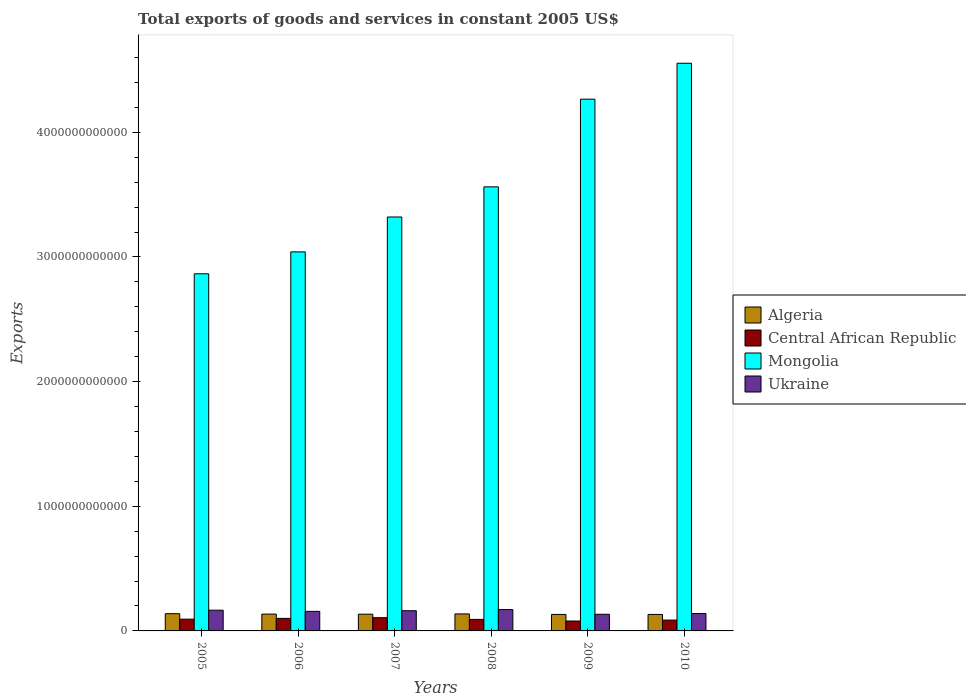How many groups of bars are there?
Provide a short and direct response. 6. How many bars are there on the 2nd tick from the right?
Make the answer very short. 4. What is the label of the 3rd group of bars from the left?
Your answer should be compact. 2007. What is the total exports of goods and services in Central African Republic in 2006?
Make the answer very short. 1.01e+11. Across all years, what is the maximum total exports of goods and services in Mongolia?
Your answer should be compact. 4.55e+12. Across all years, what is the minimum total exports of goods and services in Central African Republic?
Provide a succinct answer. 7.96e+1. In which year was the total exports of goods and services in Ukraine maximum?
Make the answer very short. 2008. What is the total total exports of goods and services in Ukraine in the graph?
Your answer should be very brief. 9.30e+11. What is the difference between the total exports of goods and services in Central African Republic in 2005 and that in 2008?
Give a very brief answer. 1.77e+09. What is the difference between the total exports of goods and services in Ukraine in 2007 and the total exports of goods and services in Algeria in 2008?
Make the answer very short. 2.56e+1. What is the average total exports of goods and services in Mongolia per year?
Ensure brevity in your answer.  3.60e+12. In the year 2007, what is the difference between the total exports of goods and services in Central African Republic and total exports of goods and services in Ukraine?
Ensure brevity in your answer.  -5.59e+1. In how many years, is the total exports of goods and services in Central African Republic greater than 2200000000000 US$?
Give a very brief answer. 0. What is the ratio of the total exports of goods and services in Central African Republic in 2005 to that in 2006?
Keep it short and to the point. 0.94. Is the total exports of goods and services in Ukraine in 2008 less than that in 2009?
Your response must be concise. No. Is the difference between the total exports of goods and services in Central African Republic in 2008 and 2010 greater than the difference between the total exports of goods and services in Ukraine in 2008 and 2010?
Your answer should be compact. No. What is the difference between the highest and the second highest total exports of goods and services in Central African Republic?
Ensure brevity in your answer.  5.52e+09. What is the difference between the highest and the lowest total exports of goods and services in Ukraine?
Ensure brevity in your answer.  3.77e+1. In how many years, is the total exports of goods and services in Algeria greater than the average total exports of goods and services in Algeria taken over all years?
Offer a very short reply. 3. What does the 2nd bar from the left in 2009 represents?
Keep it short and to the point. Central African Republic. What does the 4th bar from the right in 2007 represents?
Keep it short and to the point. Algeria. Is it the case that in every year, the sum of the total exports of goods and services in Central African Republic and total exports of goods and services in Mongolia is greater than the total exports of goods and services in Ukraine?
Your response must be concise. Yes. Are all the bars in the graph horizontal?
Offer a very short reply. No. What is the difference between two consecutive major ticks on the Y-axis?
Offer a terse response. 1.00e+12. Does the graph contain grids?
Offer a terse response. No. How are the legend labels stacked?
Your answer should be very brief. Vertical. What is the title of the graph?
Offer a terse response. Total exports of goods and services in constant 2005 US$. Does "Turks and Caicos Islands" appear as one of the legend labels in the graph?
Give a very brief answer. No. What is the label or title of the Y-axis?
Provide a succinct answer. Exports. What is the Exports of Algeria in 2005?
Offer a terse response. 1.38e+11. What is the Exports of Central African Republic in 2005?
Your answer should be compact. 9.44e+1. What is the Exports of Mongolia in 2005?
Provide a succinct answer. 2.87e+12. What is the Exports of Ukraine in 2005?
Provide a short and direct response. 1.66e+11. What is the Exports of Algeria in 2006?
Offer a terse response. 1.35e+11. What is the Exports in Central African Republic in 2006?
Keep it short and to the point. 1.01e+11. What is the Exports in Mongolia in 2006?
Your answer should be very brief. 3.04e+12. What is the Exports of Ukraine in 2006?
Provide a succinct answer. 1.57e+11. What is the Exports of Algeria in 2007?
Provide a succinct answer. 1.34e+11. What is the Exports in Central African Republic in 2007?
Keep it short and to the point. 1.06e+11. What is the Exports of Mongolia in 2007?
Make the answer very short. 3.32e+12. What is the Exports of Ukraine in 2007?
Your answer should be compact. 1.62e+11. What is the Exports in Algeria in 2008?
Your answer should be very brief. 1.36e+11. What is the Exports of Central African Republic in 2008?
Make the answer very short. 9.26e+1. What is the Exports in Mongolia in 2008?
Give a very brief answer. 3.56e+12. What is the Exports in Ukraine in 2008?
Give a very brief answer. 1.71e+11. What is the Exports of Algeria in 2009?
Make the answer very short. 1.32e+11. What is the Exports of Central African Republic in 2009?
Give a very brief answer. 7.96e+1. What is the Exports in Mongolia in 2009?
Your answer should be very brief. 4.27e+12. What is the Exports of Ukraine in 2009?
Your response must be concise. 1.34e+11. What is the Exports in Algeria in 2010?
Provide a short and direct response. 1.32e+11. What is the Exports in Central African Republic in 2010?
Your response must be concise. 8.69e+1. What is the Exports of Mongolia in 2010?
Your answer should be compact. 4.55e+12. What is the Exports of Ukraine in 2010?
Make the answer very short. 1.40e+11. Across all years, what is the maximum Exports of Algeria?
Give a very brief answer. 1.38e+11. Across all years, what is the maximum Exports of Central African Republic?
Provide a short and direct response. 1.06e+11. Across all years, what is the maximum Exports of Mongolia?
Make the answer very short. 4.55e+12. Across all years, what is the maximum Exports of Ukraine?
Your answer should be very brief. 1.71e+11. Across all years, what is the minimum Exports in Algeria?
Provide a short and direct response. 1.32e+11. Across all years, what is the minimum Exports in Central African Republic?
Give a very brief answer. 7.96e+1. Across all years, what is the minimum Exports in Mongolia?
Your answer should be compact. 2.87e+12. Across all years, what is the minimum Exports in Ukraine?
Your response must be concise. 1.34e+11. What is the total Exports of Algeria in the graph?
Your answer should be compact. 8.09e+11. What is the total Exports in Central African Republic in the graph?
Give a very brief answer. 5.60e+11. What is the total Exports of Mongolia in the graph?
Your response must be concise. 2.16e+13. What is the total Exports in Ukraine in the graph?
Make the answer very short. 9.30e+11. What is the difference between the Exports of Algeria in 2005 and that in 2006?
Your answer should be compact. 3.32e+09. What is the difference between the Exports of Central African Republic in 2005 and that in 2006?
Offer a terse response. -6.19e+09. What is the difference between the Exports in Mongolia in 2005 and that in 2006?
Keep it short and to the point. -1.76e+11. What is the difference between the Exports in Ukraine in 2005 and that in 2006?
Provide a short and direct response. 9.31e+09. What is the difference between the Exports of Algeria in 2005 and that in 2007?
Make the answer very short. 4.13e+09. What is the difference between the Exports of Central African Republic in 2005 and that in 2007?
Offer a terse response. -1.17e+1. What is the difference between the Exports of Mongolia in 2005 and that in 2007?
Provide a succinct answer. -4.56e+11. What is the difference between the Exports of Ukraine in 2005 and that in 2007?
Your answer should be very brief. 4.29e+09. What is the difference between the Exports in Algeria in 2005 and that in 2008?
Make the answer very short. 1.98e+09. What is the difference between the Exports in Central African Republic in 2005 and that in 2008?
Your answer should be very brief. 1.77e+09. What is the difference between the Exports of Mongolia in 2005 and that in 2008?
Provide a short and direct response. -6.98e+11. What is the difference between the Exports of Ukraine in 2005 and that in 2008?
Make the answer very short. -4.95e+09. What is the difference between the Exports in Algeria in 2005 and that in 2009?
Give a very brief answer. 6.13e+09. What is the difference between the Exports in Central African Republic in 2005 and that in 2009?
Ensure brevity in your answer.  1.48e+1. What is the difference between the Exports in Mongolia in 2005 and that in 2009?
Your answer should be very brief. -1.40e+12. What is the difference between the Exports of Ukraine in 2005 and that in 2009?
Your answer should be compact. 3.27e+1. What is the difference between the Exports in Algeria in 2005 and that in 2010?
Give a very brief answer. 6.13e+09. What is the difference between the Exports in Central African Republic in 2005 and that in 2010?
Provide a short and direct response. 7.48e+09. What is the difference between the Exports of Mongolia in 2005 and that in 2010?
Make the answer very short. -1.69e+12. What is the difference between the Exports of Ukraine in 2005 and that in 2010?
Your answer should be compact. 2.67e+1. What is the difference between the Exports of Algeria in 2006 and that in 2007?
Provide a succinct answer. 8.11e+08. What is the difference between the Exports in Central African Republic in 2006 and that in 2007?
Make the answer very short. -5.52e+09. What is the difference between the Exports in Mongolia in 2006 and that in 2007?
Ensure brevity in your answer.  -2.80e+11. What is the difference between the Exports of Ukraine in 2006 and that in 2007?
Give a very brief answer. -5.02e+09. What is the difference between the Exports in Algeria in 2006 and that in 2008?
Offer a very short reply. -1.34e+09. What is the difference between the Exports in Central African Republic in 2006 and that in 2008?
Keep it short and to the point. 7.97e+09. What is the difference between the Exports in Mongolia in 2006 and that in 2008?
Give a very brief answer. -5.22e+11. What is the difference between the Exports of Ukraine in 2006 and that in 2008?
Provide a short and direct response. -1.43e+1. What is the difference between the Exports of Algeria in 2006 and that in 2009?
Ensure brevity in your answer.  2.81e+09. What is the difference between the Exports of Central African Republic in 2006 and that in 2009?
Make the answer very short. 2.10e+1. What is the difference between the Exports of Mongolia in 2006 and that in 2009?
Provide a short and direct response. -1.23e+12. What is the difference between the Exports in Ukraine in 2006 and that in 2009?
Give a very brief answer. 2.34e+1. What is the difference between the Exports in Algeria in 2006 and that in 2010?
Ensure brevity in your answer.  2.81e+09. What is the difference between the Exports of Central African Republic in 2006 and that in 2010?
Give a very brief answer. 1.37e+1. What is the difference between the Exports in Mongolia in 2006 and that in 2010?
Give a very brief answer. -1.51e+12. What is the difference between the Exports in Ukraine in 2006 and that in 2010?
Provide a succinct answer. 1.74e+1. What is the difference between the Exports of Algeria in 2007 and that in 2008?
Offer a very short reply. -2.15e+09. What is the difference between the Exports in Central African Republic in 2007 and that in 2008?
Your answer should be compact. 1.35e+1. What is the difference between the Exports of Mongolia in 2007 and that in 2008?
Keep it short and to the point. -2.42e+11. What is the difference between the Exports in Ukraine in 2007 and that in 2008?
Keep it short and to the point. -9.23e+09. What is the difference between the Exports in Algeria in 2007 and that in 2009?
Your answer should be very brief. 2.00e+09. What is the difference between the Exports of Central African Republic in 2007 and that in 2009?
Your response must be concise. 2.65e+1. What is the difference between the Exports in Mongolia in 2007 and that in 2009?
Keep it short and to the point. -9.45e+11. What is the difference between the Exports in Ukraine in 2007 and that in 2009?
Offer a terse response. 2.84e+1. What is the difference between the Exports of Algeria in 2007 and that in 2010?
Make the answer very short. 2.00e+09. What is the difference between the Exports in Central African Republic in 2007 and that in 2010?
Give a very brief answer. 1.92e+1. What is the difference between the Exports of Mongolia in 2007 and that in 2010?
Give a very brief answer. -1.23e+12. What is the difference between the Exports in Ukraine in 2007 and that in 2010?
Provide a short and direct response. 2.24e+1. What is the difference between the Exports in Algeria in 2008 and that in 2009?
Your answer should be very brief. 4.15e+09. What is the difference between the Exports of Central African Republic in 2008 and that in 2009?
Offer a very short reply. 1.30e+1. What is the difference between the Exports of Mongolia in 2008 and that in 2009?
Keep it short and to the point. -7.04e+11. What is the difference between the Exports of Ukraine in 2008 and that in 2009?
Your answer should be compact. 3.77e+1. What is the difference between the Exports in Algeria in 2008 and that in 2010?
Offer a terse response. 4.15e+09. What is the difference between the Exports of Central African Republic in 2008 and that in 2010?
Ensure brevity in your answer.  5.71e+09. What is the difference between the Exports in Mongolia in 2008 and that in 2010?
Your answer should be very brief. -9.92e+11. What is the difference between the Exports of Ukraine in 2008 and that in 2010?
Offer a terse response. 3.17e+1. What is the difference between the Exports of Central African Republic in 2009 and that in 2010?
Your answer should be very brief. -7.29e+09. What is the difference between the Exports of Mongolia in 2009 and that in 2010?
Provide a short and direct response. -2.88e+11. What is the difference between the Exports of Ukraine in 2009 and that in 2010?
Provide a succinct answer. -6.01e+09. What is the difference between the Exports of Algeria in 2005 and the Exports of Central African Republic in 2006?
Offer a very short reply. 3.79e+1. What is the difference between the Exports of Algeria in 2005 and the Exports of Mongolia in 2006?
Provide a short and direct response. -2.90e+12. What is the difference between the Exports of Algeria in 2005 and the Exports of Ukraine in 2006?
Offer a very short reply. -1.86e+1. What is the difference between the Exports of Central African Republic in 2005 and the Exports of Mongolia in 2006?
Make the answer very short. -2.95e+12. What is the difference between the Exports of Central African Republic in 2005 and the Exports of Ukraine in 2006?
Make the answer very short. -6.26e+1. What is the difference between the Exports in Mongolia in 2005 and the Exports in Ukraine in 2006?
Make the answer very short. 2.71e+12. What is the difference between the Exports in Algeria in 2005 and the Exports in Central African Republic in 2007?
Make the answer very short. 3.23e+1. What is the difference between the Exports of Algeria in 2005 and the Exports of Mongolia in 2007?
Your response must be concise. -3.18e+12. What is the difference between the Exports in Algeria in 2005 and the Exports in Ukraine in 2007?
Give a very brief answer. -2.36e+1. What is the difference between the Exports in Central African Republic in 2005 and the Exports in Mongolia in 2007?
Make the answer very short. -3.23e+12. What is the difference between the Exports of Central African Republic in 2005 and the Exports of Ukraine in 2007?
Ensure brevity in your answer.  -6.77e+1. What is the difference between the Exports of Mongolia in 2005 and the Exports of Ukraine in 2007?
Provide a succinct answer. 2.70e+12. What is the difference between the Exports of Algeria in 2005 and the Exports of Central African Republic in 2008?
Ensure brevity in your answer.  4.58e+1. What is the difference between the Exports of Algeria in 2005 and the Exports of Mongolia in 2008?
Offer a terse response. -3.42e+12. What is the difference between the Exports of Algeria in 2005 and the Exports of Ukraine in 2008?
Give a very brief answer. -3.28e+1. What is the difference between the Exports in Central African Republic in 2005 and the Exports in Mongolia in 2008?
Your answer should be compact. -3.47e+12. What is the difference between the Exports in Central African Republic in 2005 and the Exports in Ukraine in 2008?
Provide a succinct answer. -7.69e+1. What is the difference between the Exports in Mongolia in 2005 and the Exports in Ukraine in 2008?
Give a very brief answer. 2.69e+12. What is the difference between the Exports in Algeria in 2005 and the Exports in Central African Republic in 2009?
Ensure brevity in your answer.  5.88e+1. What is the difference between the Exports in Algeria in 2005 and the Exports in Mongolia in 2009?
Offer a very short reply. -4.13e+12. What is the difference between the Exports in Algeria in 2005 and the Exports in Ukraine in 2009?
Offer a terse response. 4.85e+09. What is the difference between the Exports in Central African Republic in 2005 and the Exports in Mongolia in 2009?
Offer a very short reply. -4.17e+12. What is the difference between the Exports in Central African Republic in 2005 and the Exports in Ukraine in 2009?
Offer a terse response. -3.92e+1. What is the difference between the Exports of Mongolia in 2005 and the Exports of Ukraine in 2009?
Your response must be concise. 2.73e+12. What is the difference between the Exports of Algeria in 2005 and the Exports of Central African Republic in 2010?
Your answer should be compact. 5.15e+1. What is the difference between the Exports in Algeria in 2005 and the Exports in Mongolia in 2010?
Offer a very short reply. -4.42e+12. What is the difference between the Exports in Algeria in 2005 and the Exports in Ukraine in 2010?
Keep it short and to the point. -1.16e+09. What is the difference between the Exports in Central African Republic in 2005 and the Exports in Mongolia in 2010?
Ensure brevity in your answer.  -4.46e+12. What is the difference between the Exports in Central African Republic in 2005 and the Exports in Ukraine in 2010?
Your response must be concise. -4.52e+1. What is the difference between the Exports of Mongolia in 2005 and the Exports of Ukraine in 2010?
Your answer should be very brief. 2.73e+12. What is the difference between the Exports of Algeria in 2006 and the Exports of Central African Republic in 2007?
Keep it short and to the point. 2.90e+1. What is the difference between the Exports in Algeria in 2006 and the Exports in Mongolia in 2007?
Your answer should be very brief. -3.19e+12. What is the difference between the Exports of Algeria in 2006 and the Exports of Ukraine in 2007?
Keep it short and to the point. -2.69e+1. What is the difference between the Exports in Central African Republic in 2006 and the Exports in Mongolia in 2007?
Ensure brevity in your answer.  -3.22e+12. What is the difference between the Exports in Central African Republic in 2006 and the Exports in Ukraine in 2007?
Your answer should be compact. -6.15e+1. What is the difference between the Exports in Mongolia in 2006 and the Exports in Ukraine in 2007?
Keep it short and to the point. 2.88e+12. What is the difference between the Exports of Algeria in 2006 and the Exports of Central African Republic in 2008?
Provide a short and direct response. 4.25e+1. What is the difference between the Exports of Algeria in 2006 and the Exports of Mongolia in 2008?
Provide a short and direct response. -3.43e+12. What is the difference between the Exports in Algeria in 2006 and the Exports in Ukraine in 2008?
Make the answer very short. -3.62e+1. What is the difference between the Exports of Central African Republic in 2006 and the Exports of Mongolia in 2008?
Offer a very short reply. -3.46e+12. What is the difference between the Exports of Central African Republic in 2006 and the Exports of Ukraine in 2008?
Your response must be concise. -7.07e+1. What is the difference between the Exports in Mongolia in 2006 and the Exports in Ukraine in 2008?
Your answer should be very brief. 2.87e+12. What is the difference between the Exports in Algeria in 2006 and the Exports in Central African Republic in 2009?
Give a very brief answer. 5.55e+1. What is the difference between the Exports in Algeria in 2006 and the Exports in Mongolia in 2009?
Offer a terse response. -4.13e+12. What is the difference between the Exports in Algeria in 2006 and the Exports in Ukraine in 2009?
Keep it short and to the point. 1.52e+09. What is the difference between the Exports of Central African Republic in 2006 and the Exports of Mongolia in 2009?
Your answer should be very brief. -4.17e+12. What is the difference between the Exports in Central African Republic in 2006 and the Exports in Ukraine in 2009?
Make the answer very short. -3.30e+1. What is the difference between the Exports in Mongolia in 2006 and the Exports in Ukraine in 2009?
Offer a very short reply. 2.91e+12. What is the difference between the Exports in Algeria in 2006 and the Exports in Central African Republic in 2010?
Your answer should be compact. 4.82e+1. What is the difference between the Exports of Algeria in 2006 and the Exports of Mongolia in 2010?
Your answer should be very brief. -4.42e+12. What is the difference between the Exports of Algeria in 2006 and the Exports of Ukraine in 2010?
Your response must be concise. -4.49e+09. What is the difference between the Exports in Central African Republic in 2006 and the Exports in Mongolia in 2010?
Your answer should be compact. -4.45e+12. What is the difference between the Exports of Central African Republic in 2006 and the Exports of Ukraine in 2010?
Ensure brevity in your answer.  -3.90e+1. What is the difference between the Exports of Mongolia in 2006 and the Exports of Ukraine in 2010?
Make the answer very short. 2.90e+12. What is the difference between the Exports in Algeria in 2007 and the Exports in Central African Republic in 2008?
Offer a very short reply. 4.17e+1. What is the difference between the Exports in Algeria in 2007 and the Exports in Mongolia in 2008?
Make the answer very short. -3.43e+12. What is the difference between the Exports in Algeria in 2007 and the Exports in Ukraine in 2008?
Make the answer very short. -3.70e+1. What is the difference between the Exports of Central African Republic in 2007 and the Exports of Mongolia in 2008?
Make the answer very short. -3.46e+12. What is the difference between the Exports in Central African Republic in 2007 and the Exports in Ukraine in 2008?
Keep it short and to the point. -6.52e+1. What is the difference between the Exports in Mongolia in 2007 and the Exports in Ukraine in 2008?
Your answer should be compact. 3.15e+12. What is the difference between the Exports of Algeria in 2007 and the Exports of Central African Republic in 2009?
Provide a short and direct response. 5.47e+1. What is the difference between the Exports in Algeria in 2007 and the Exports in Mongolia in 2009?
Offer a terse response. -4.13e+12. What is the difference between the Exports of Algeria in 2007 and the Exports of Ukraine in 2009?
Offer a terse response. 7.13e+08. What is the difference between the Exports in Central African Republic in 2007 and the Exports in Mongolia in 2009?
Provide a succinct answer. -4.16e+12. What is the difference between the Exports of Central African Republic in 2007 and the Exports of Ukraine in 2009?
Provide a short and direct response. -2.75e+1. What is the difference between the Exports of Mongolia in 2007 and the Exports of Ukraine in 2009?
Make the answer very short. 3.19e+12. What is the difference between the Exports in Algeria in 2007 and the Exports in Central African Republic in 2010?
Offer a very short reply. 4.74e+1. What is the difference between the Exports in Algeria in 2007 and the Exports in Mongolia in 2010?
Your answer should be compact. -4.42e+12. What is the difference between the Exports of Algeria in 2007 and the Exports of Ukraine in 2010?
Offer a very short reply. -5.30e+09. What is the difference between the Exports of Central African Republic in 2007 and the Exports of Mongolia in 2010?
Keep it short and to the point. -4.45e+12. What is the difference between the Exports in Central African Republic in 2007 and the Exports in Ukraine in 2010?
Your response must be concise. -3.35e+1. What is the difference between the Exports in Mongolia in 2007 and the Exports in Ukraine in 2010?
Ensure brevity in your answer.  3.18e+12. What is the difference between the Exports of Algeria in 2008 and the Exports of Central African Republic in 2009?
Your response must be concise. 5.69e+1. What is the difference between the Exports of Algeria in 2008 and the Exports of Mongolia in 2009?
Give a very brief answer. -4.13e+12. What is the difference between the Exports of Algeria in 2008 and the Exports of Ukraine in 2009?
Make the answer very short. 2.86e+09. What is the difference between the Exports of Central African Republic in 2008 and the Exports of Mongolia in 2009?
Provide a short and direct response. -4.17e+12. What is the difference between the Exports in Central African Republic in 2008 and the Exports in Ukraine in 2009?
Ensure brevity in your answer.  -4.10e+1. What is the difference between the Exports of Mongolia in 2008 and the Exports of Ukraine in 2009?
Your response must be concise. 3.43e+12. What is the difference between the Exports of Algeria in 2008 and the Exports of Central African Republic in 2010?
Ensure brevity in your answer.  4.96e+1. What is the difference between the Exports of Algeria in 2008 and the Exports of Mongolia in 2010?
Your response must be concise. -4.42e+12. What is the difference between the Exports of Algeria in 2008 and the Exports of Ukraine in 2010?
Offer a very short reply. -3.15e+09. What is the difference between the Exports of Central African Republic in 2008 and the Exports of Mongolia in 2010?
Make the answer very short. -4.46e+12. What is the difference between the Exports of Central African Republic in 2008 and the Exports of Ukraine in 2010?
Your response must be concise. -4.70e+1. What is the difference between the Exports in Mongolia in 2008 and the Exports in Ukraine in 2010?
Ensure brevity in your answer.  3.42e+12. What is the difference between the Exports of Algeria in 2009 and the Exports of Central African Republic in 2010?
Provide a short and direct response. 4.54e+1. What is the difference between the Exports in Algeria in 2009 and the Exports in Mongolia in 2010?
Provide a succinct answer. -4.42e+12. What is the difference between the Exports of Algeria in 2009 and the Exports of Ukraine in 2010?
Your answer should be very brief. -7.29e+09. What is the difference between the Exports of Central African Republic in 2009 and the Exports of Mongolia in 2010?
Your answer should be compact. -4.47e+12. What is the difference between the Exports of Central African Republic in 2009 and the Exports of Ukraine in 2010?
Provide a short and direct response. -6.00e+1. What is the difference between the Exports of Mongolia in 2009 and the Exports of Ukraine in 2010?
Provide a short and direct response. 4.13e+12. What is the average Exports of Algeria per year?
Ensure brevity in your answer.  1.35e+11. What is the average Exports in Central African Republic per year?
Give a very brief answer. 9.33e+1. What is the average Exports of Mongolia per year?
Make the answer very short. 3.60e+12. What is the average Exports in Ukraine per year?
Your answer should be compact. 1.55e+11. In the year 2005, what is the difference between the Exports of Algeria and Exports of Central African Republic?
Keep it short and to the point. 4.41e+1. In the year 2005, what is the difference between the Exports in Algeria and Exports in Mongolia?
Keep it short and to the point. -2.73e+12. In the year 2005, what is the difference between the Exports in Algeria and Exports in Ukraine?
Provide a short and direct response. -2.79e+1. In the year 2005, what is the difference between the Exports of Central African Republic and Exports of Mongolia?
Offer a terse response. -2.77e+12. In the year 2005, what is the difference between the Exports in Central African Republic and Exports in Ukraine?
Provide a succinct answer. -7.19e+1. In the year 2005, what is the difference between the Exports in Mongolia and Exports in Ukraine?
Give a very brief answer. 2.70e+12. In the year 2006, what is the difference between the Exports of Algeria and Exports of Central African Republic?
Your answer should be compact. 3.45e+1. In the year 2006, what is the difference between the Exports of Algeria and Exports of Mongolia?
Offer a terse response. -2.91e+12. In the year 2006, what is the difference between the Exports in Algeria and Exports in Ukraine?
Provide a succinct answer. -2.19e+1. In the year 2006, what is the difference between the Exports in Central African Republic and Exports in Mongolia?
Ensure brevity in your answer.  -2.94e+12. In the year 2006, what is the difference between the Exports in Central African Republic and Exports in Ukraine?
Make the answer very short. -5.64e+1. In the year 2006, what is the difference between the Exports in Mongolia and Exports in Ukraine?
Keep it short and to the point. 2.88e+12. In the year 2007, what is the difference between the Exports in Algeria and Exports in Central African Republic?
Offer a very short reply. 2.82e+1. In the year 2007, what is the difference between the Exports of Algeria and Exports of Mongolia?
Your answer should be compact. -3.19e+12. In the year 2007, what is the difference between the Exports of Algeria and Exports of Ukraine?
Keep it short and to the point. -2.77e+1. In the year 2007, what is the difference between the Exports of Central African Republic and Exports of Mongolia?
Your answer should be compact. -3.21e+12. In the year 2007, what is the difference between the Exports in Central African Republic and Exports in Ukraine?
Offer a very short reply. -5.59e+1. In the year 2007, what is the difference between the Exports in Mongolia and Exports in Ukraine?
Offer a terse response. 3.16e+12. In the year 2008, what is the difference between the Exports of Algeria and Exports of Central African Republic?
Your response must be concise. 4.38e+1. In the year 2008, what is the difference between the Exports in Algeria and Exports in Mongolia?
Offer a terse response. -3.43e+12. In the year 2008, what is the difference between the Exports in Algeria and Exports in Ukraine?
Your answer should be very brief. -3.48e+1. In the year 2008, what is the difference between the Exports of Central African Republic and Exports of Mongolia?
Your answer should be very brief. -3.47e+12. In the year 2008, what is the difference between the Exports in Central African Republic and Exports in Ukraine?
Make the answer very short. -7.87e+1. In the year 2008, what is the difference between the Exports of Mongolia and Exports of Ukraine?
Your answer should be compact. 3.39e+12. In the year 2009, what is the difference between the Exports of Algeria and Exports of Central African Republic?
Make the answer very short. 5.27e+1. In the year 2009, what is the difference between the Exports in Algeria and Exports in Mongolia?
Make the answer very short. -4.13e+12. In the year 2009, what is the difference between the Exports of Algeria and Exports of Ukraine?
Your answer should be very brief. -1.28e+09. In the year 2009, what is the difference between the Exports of Central African Republic and Exports of Mongolia?
Offer a terse response. -4.19e+12. In the year 2009, what is the difference between the Exports in Central African Republic and Exports in Ukraine?
Make the answer very short. -5.40e+1. In the year 2009, what is the difference between the Exports in Mongolia and Exports in Ukraine?
Your answer should be compact. 4.13e+12. In the year 2010, what is the difference between the Exports in Algeria and Exports in Central African Republic?
Make the answer very short. 4.54e+1. In the year 2010, what is the difference between the Exports in Algeria and Exports in Mongolia?
Provide a succinct answer. -4.42e+12. In the year 2010, what is the difference between the Exports of Algeria and Exports of Ukraine?
Provide a short and direct response. -7.29e+09. In the year 2010, what is the difference between the Exports in Central African Republic and Exports in Mongolia?
Offer a very short reply. -4.47e+12. In the year 2010, what is the difference between the Exports in Central African Republic and Exports in Ukraine?
Your answer should be compact. -5.27e+1. In the year 2010, what is the difference between the Exports in Mongolia and Exports in Ukraine?
Your response must be concise. 4.41e+12. What is the ratio of the Exports of Algeria in 2005 to that in 2006?
Offer a very short reply. 1.02. What is the ratio of the Exports of Central African Republic in 2005 to that in 2006?
Provide a short and direct response. 0.94. What is the ratio of the Exports of Mongolia in 2005 to that in 2006?
Provide a succinct answer. 0.94. What is the ratio of the Exports in Ukraine in 2005 to that in 2006?
Make the answer very short. 1.06. What is the ratio of the Exports of Algeria in 2005 to that in 2007?
Ensure brevity in your answer.  1.03. What is the ratio of the Exports in Central African Republic in 2005 to that in 2007?
Your answer should be compact. 0.89. What is the ratio of the Exports of Mongolia in 2005 to that in 2007?
Ensure brevity in your answer.  0.86. What is the ratio of the Exports of Ukraine in 2005 to that in 2007?
Offer a terse response. 1.03. What is the ratio of the Exports of Algeria in 2005 to that in 2008?
Your answer should be compact. 1.01. What is the ratio of the Exports in Central African Republic in 2005 to that in 2008?
Your response must be concise. 1.02. What is the ratio of the Exports of Mongolia in 2005 to that in 2008?
Ensure brevity in your answer.  0.8. What is the ratio of the Exports of Ukraine in 2005 to that in 2008?
Keep it short and to the point. 0.97. What is the ratio of the Exports of Algeria in 2005 to that in 2009?
Offer a very short reply. 1.05. What is the ratio of the Exports in Central African Republic in 2005 to that in 2009?
Offer a very short reply. 1.19. What is the ratio of the Exports in Mongolia in 2005 to that in 2009?
Give a very brief answer. 0.67. What is the ratio of the Exports in Ukraine in 2005 to that in 2009?
Offer a terse response. 1.25. What is the ratio of the Exports in Algeria in 2005 to that in 2010?
Ensure brevity in your answer.  1.05. What is the ratio of the Exports of Central African Republic in 2005 to that in 2010?
Your answer should be very brief. 1.09. What is the ratio of the Exports of Mongolia in 2005 to that in 2010?
Make the answer very short. 0.63. What is the ratio of the Exports of Ukraine in 2005 to that in 2010?
Make the answer very short. 1.19. What is the ratio of the Exports in Central African Republic in 2006 to that in 2007?
Your response must be concise. 0.95. What is the ratio of the Exports in Mongolia in 2006 to that in 2007?
Ensure brevity in your answer.  0.92. What is the ratio of the Exports of Algeria in 2006 to that in 2008?
Give a very brief answer. 0.99. What is the ratio of the Exports in Central African Republic in 2006 to that in 2008?
Give a very brief answer. 1.09. What is the ratio of the Exports of Mongolia in 2006 to that in 2008?
Ensure brevity in your answer.  0.85. What is the ratio of the Exports in Ukraine in 2006 to that in 2008?
Your answer should be compact. 0.92. What is the ratio of the Exports of Algeria in 2006 to that in 2009?
Your answer should be very brief. 1.02. What is the ratio of the Exports of Central African Republic in 2006 to that in 2009?
Ensure brevity in your answer.  1.26. What is the ratio of the Exports of Mongolia in 2006 to that in 2009?
Ensure brevity in your answer.  0.71. What is the ratio of the Exports in Ukraine in 2006 to that in 2009?
Give a very brief answer. 1.18. What is the ratio of the Exports of Algeria in 2006 to that in 2010?
Your response must be concise. 1.02. What is the ratio of the Exports in Central African Republic in 2006 to that in 2010?
Provide a succinct answer. 1.16. What is the ratio of the Exports of Mongolia in 2006 to that in 2010?
Your answer should be very brief. 0.67. What is the ratio of the Exports in Ukraine in 2006 to that in 2010?
Provide a succinct answer. 1.12. What is the ratio of the Exports of Algeria in 2007 to that in 2008?
Your answer should be compact. 0.98. What is the ratio of the Exports of Central African Republic in 2007 to that in 2008?
Make the answer very short. 1.15. What is the ratio of the Exports in Mongolia in 2007 to that in 2008?
Offer a terse response. 0.93. What is the ratio of the Exports of Ukraine in 2007 to that in 2008?
Offer a very short reply. 0.95. What is the ratio of the Exports in Algeria in 2007 to that in 2009?
Offer a very short reply. 1.02. What is the ratio of the Exports in Central African Republic in 2007 to that in 2009?
Offer a very short reply. 1.33. What is the ratio of the Exports in Mongolia in 2007 to that in 2009?
Make the answer very short. 0.78. What is the ratio of the Exports of Ukraine in 2007 to that in 2009?
Give a very brief answer. 1.21. What is the ratio of the Exports in Algeria in 2007 to that in 2010?
Offer a very short reply. 1.02. What is the ratio of the Exports in Central African Republic in 2007 to that in 2010?
Make the answer very short. 1.22. What is the ratio of the Exports of Mongolia in 2007 to that in 2010?
Give a very brief answer. 0.73. What is the ratio of the Exports of Ukraine in 2007 to that in 2010?
Make the answer very short. 1.16. What is the ratio of the Exports in Algeria in 2008 to that in 2009?
Give a very brief answer. 1.03. What is the ratio of the Exports in Central African Republic in 2008 to that in 2009?
Your answer should be compact. 1.16. What is the ratio of the Exports of Mongolia in 2008 to that in 2009?
Offer a terse response. 0.84. What is the ratio of the Exports in Ukraine in 2008 to that in 2009?
Provide a short and direct response. 1.28. What is the ratio of the Exports in Algeria in 2008 to that in 2010?
Offer a very short reply. 1.03. What is the ratio of the Exports of Central African Republic in 2008 to that in 2010?
Keep it short and to the point. 1.07. What is the ratio of the Exports of Mongolia in 2008 to that in 2010?
Provide a short and direct response. 0.78. What is the ratio of the Exports of Ukraine in 2008 to that in 2010?
Provide a succinct answer. 1.23. What is the ratio of the Exports in Algeria in 2009 to that in 2010?
Provide a succinct answer. 1. What is the ratio of the Exports of Central African Republic in 2009 to that in 2010?
Give a very brief answer. 0.92. What is the ratio of the Exports of Mongolia in 2009 to that in 2010?
Your answer should be very brief. 0.94. What is the ratio of the Exports in Ukraine in 2009 to that in 2010?
Ensure brevity in your answer.  0.96. What is the difference between the highest and the second highest Exports of Algeria?
Provide a succinct answer. 1.98e+09. What is the difference between the highest and the second highest Exports of Central African Republic?
Keep it short and to the point. 5.52e+09. What is the difference between the highest and the second highest Exports in Mongolia?
Your response must be concise. 2.88e+11. What is the difference between the highest and the second highest Exports of Ukraine?
Your answer should be compact. 4.95e+09. What is the difference between the highest and the lowest Exports in Algeria?
Give a very brief answer. 6.13e+09. What is the difference between the highest and the lowest Exports of Central African Republic?
Your answer should be very brief. 2.65e+1. What is the difference between the highest and the lowest Exports of Mongolia?
Ensure brevity in your answer.  1.69e+12. What is the difference between the highest and the lowest Exports in Ukraine?
Provide a short and direct response. 3.77e+1. 